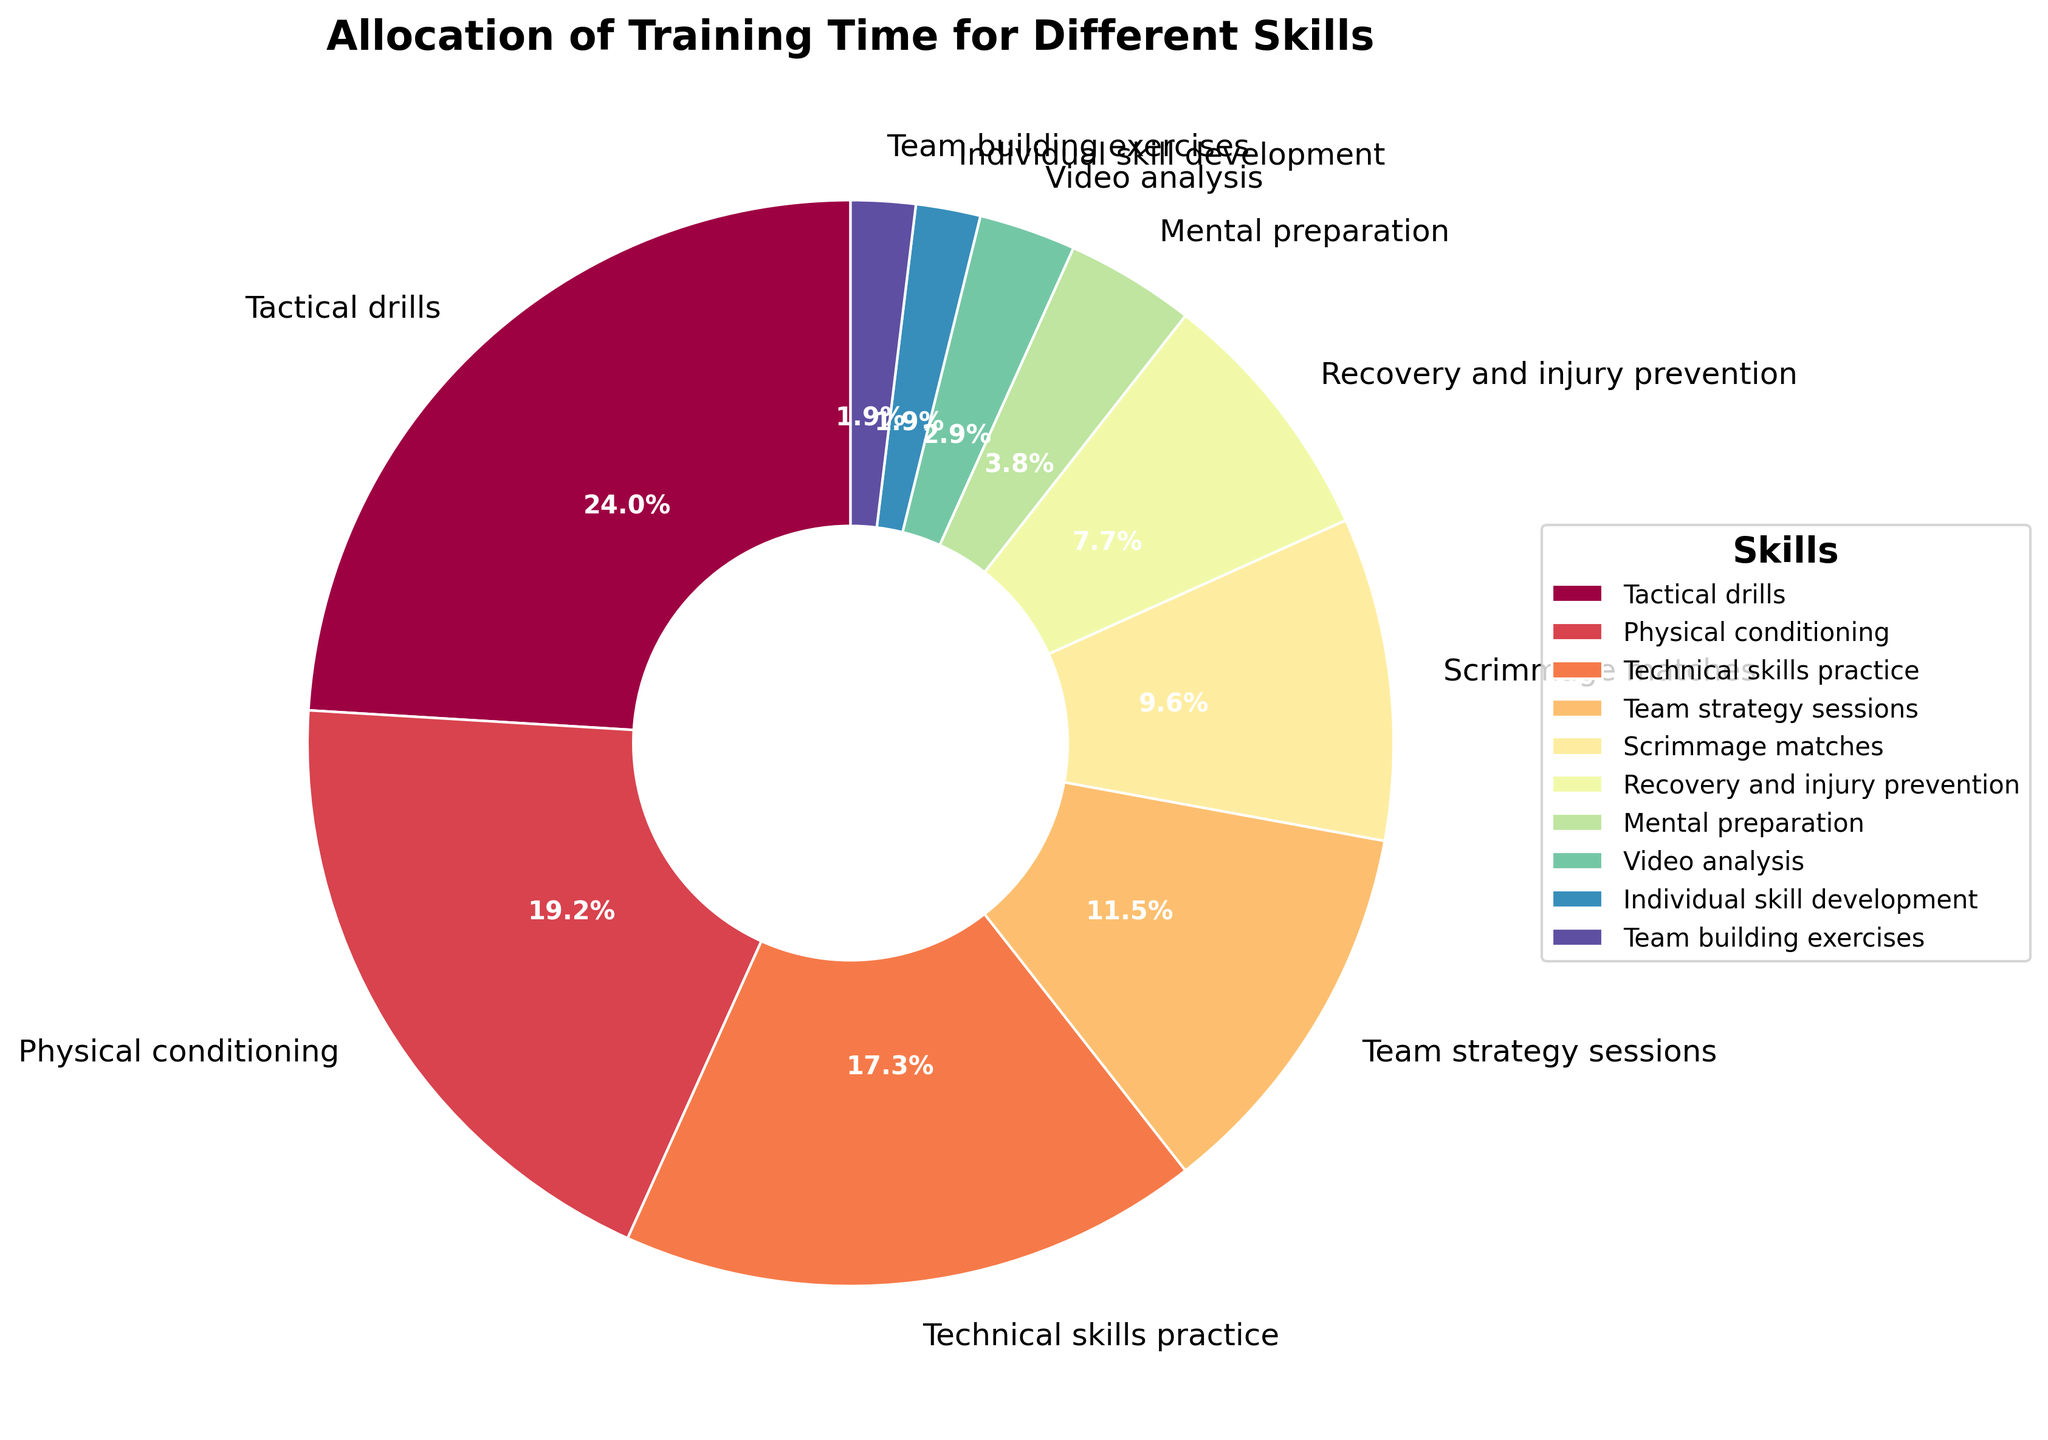How much of the team's training time is allocated to Tactical drills and Team strategy sessions combined? Add the percentages for Tactical drills (25%) and Team strategy sessions (12%): 25 + 12 = 37%.
Answer: 37% Which skill receives the least amount of training time? The skill with the smallest percentage on the chart is Individual skill development and Team building exercises, each with 2%.
Answer: Individual skill development and Team building exercises What is the difference in training time between Technical skills practice and Physical conditioning? Subtract the percentage of Physical conditioning (20%) from Technical skills practice (18%): 20 - 18 = 2%.
Answer: 2% Is more time spent on Mental preparation or on Video analysis? Compare the percentages for Mental preparation (4%) and Video analysis (3%): 4% is greater than 3%.
Answer: Mental preparation What percentage of the training time is dedicated to Recovery and injury prevention? Locate the percentage for Recovery and injury prevention on the chart, which is 8%.
Answer: 8% What fraction of the training time is allocated to Scrimmage matches compared to Tactical drills? Divide the percentage of Scrimmage matches (10%) by the percentage of Tactical drills (25%): 10/25 = 2/5 or 0.4.
Answer: 0.4 (or 2/5) Which two skills have a combined training time equal to that of Tactical drills? Add the percentages for Physical conditioning (20%) and Video analysis (3%) to compare with Tactical drills (25%): 20 + 3 = 23, which is less than 25. Instead, adding Technical skills practice (18%) and Recovery and injury prevention (8%): 18 + 8 = 26, which is more than 25, so it's not correct. Adding Team strategy sessions (12%) and Scrimmage matches (10%): 12 + 10 = 22, which is close. Thus, no exact match, but adding Physical conditioning (20%) with Individual skill development (2%): 20 + 2 = 22, close to 25.
Answer: No exact match, closest: Technical skills practice and Recovery and injury prevention (1% more) and Physical conditioning and Individual skill development (3% less) Compare the allocation of training time for Recovery and injury prevention with Mental preparation and Video analysis combined. Add the percentages for Mental preparation (4%) and Video analysis (3%): 4 + 3 = 7%. Compare this with Recovery and injury prevention (8%): 8% is greater than 7%.
Answer: Recovery and injury prevention (8%) is greater What is the total percentage of training time dedicated to skills other than Tactical drills and Physical conditioning? Subtract the combined percentage of Tactical drills (25%) and Physical conditioning (20%) from 100%: 25 + 20 = 45, and 100 - 45 = 55.
Answer: 55% How does the training time for Team building exercises compare to Individual skill development? Both skills have the same percentage allocated on the chart, which is 2%.
Answer: Equal 